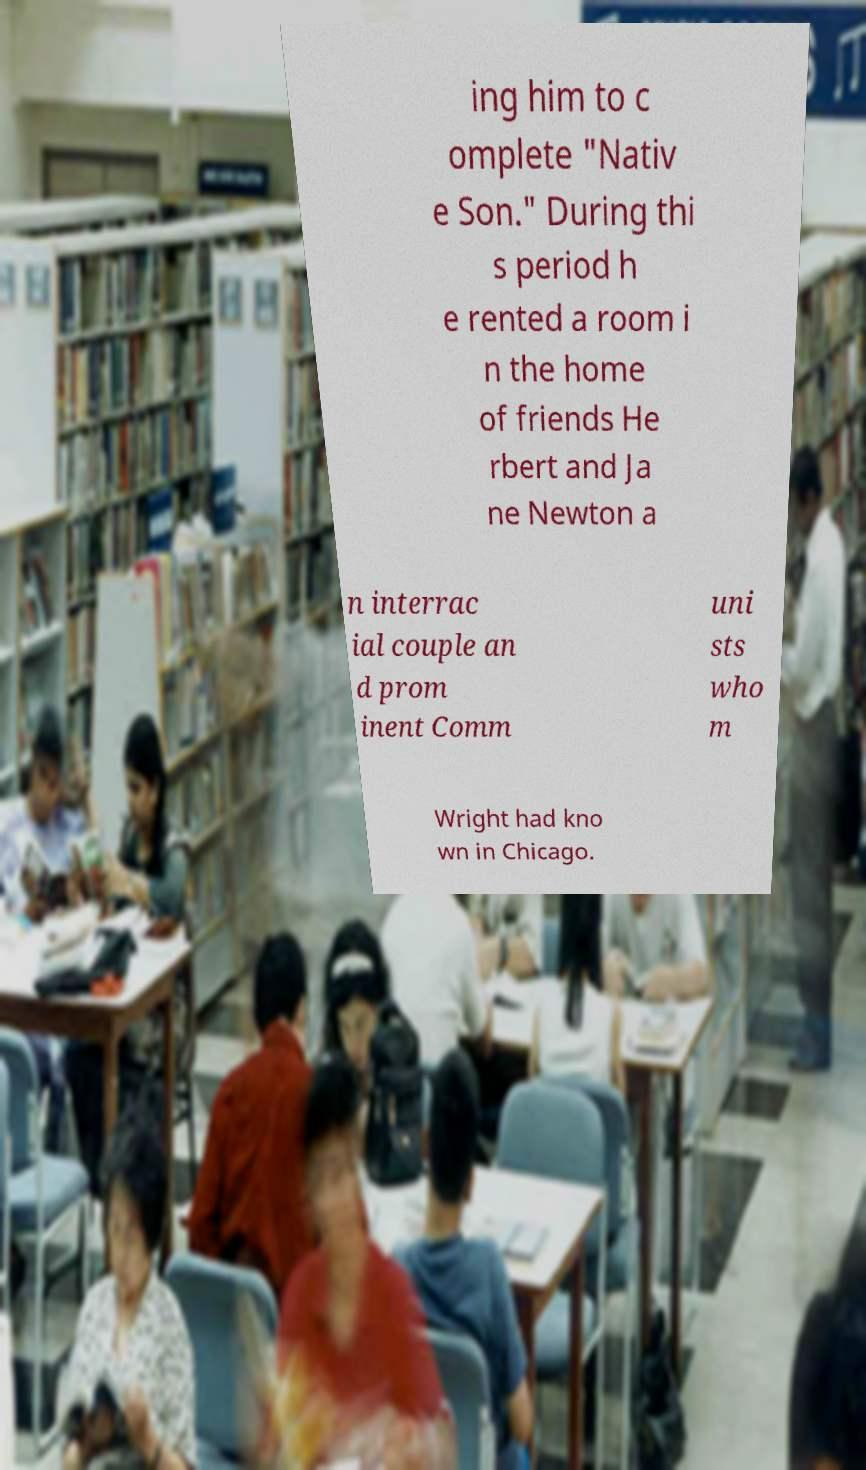Please read and relay the text visible in this image. What does it say? ing him to c omplete "Nativ e Son." During thi s period h e rented a room i n the home of friends He rbert and Ja ne Newton a n interrac ial couple an d prom inent Comm uni sts who m Wright had kno wn in Chicago. 